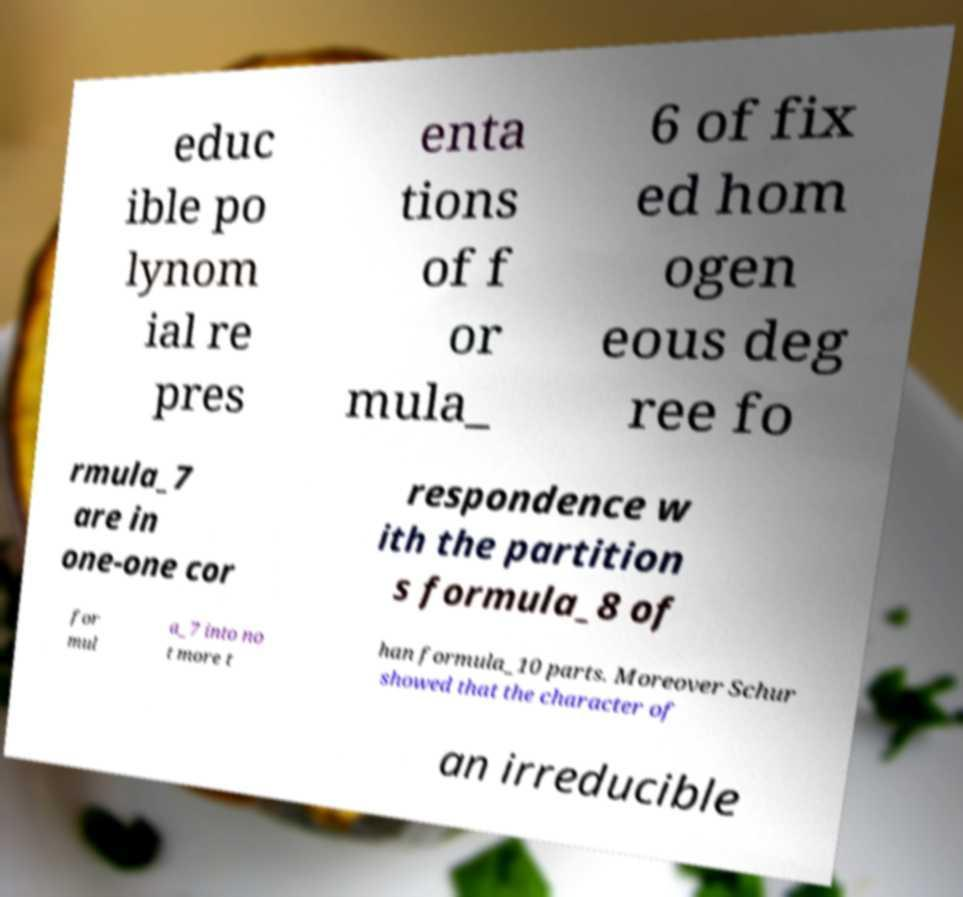For documentation purposes, I need the text within this image transcribed. Could you provide that? educ ible po lynom ial re pres enta tions of f or mula_ 6 of fix ed hom ogen eous deg ree fo rmula_7 are in one-one cor respondence w ith the partition s formula_8 of for mul a_7 into no t more t han formula_10 parts. Moreover Schur showed that the character of an irreducible 